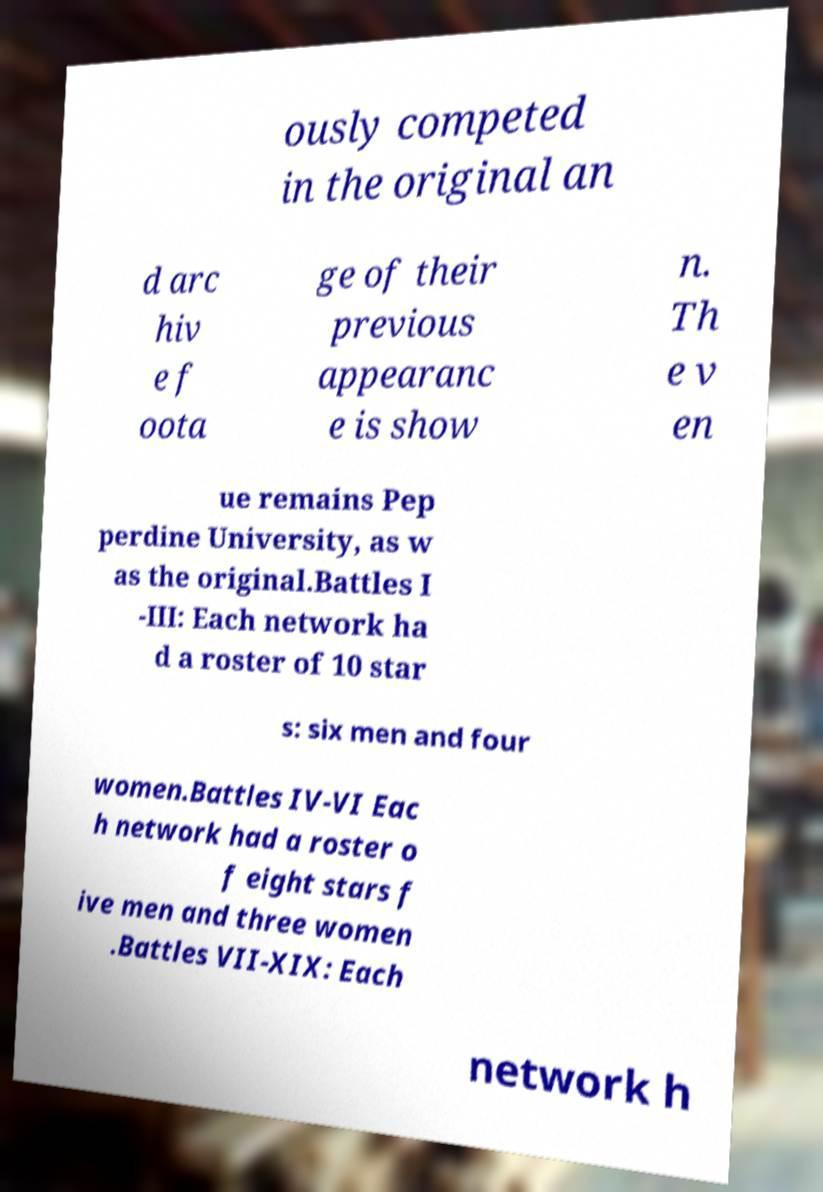Please read and relay the text visible in this image. What does it say? ously competed in the original an d arc hiv e f oota ge of their previous appearanc e is show n. Th e v en ue remains Pep perdine University, as w as the original.Battles I -III: Each network ha d a roster of 10 star s: six men and four women.Battles IV-VI Eac h network had a roster o f eight stars f ive men and three women .Battles VII-XIX: Each network h 